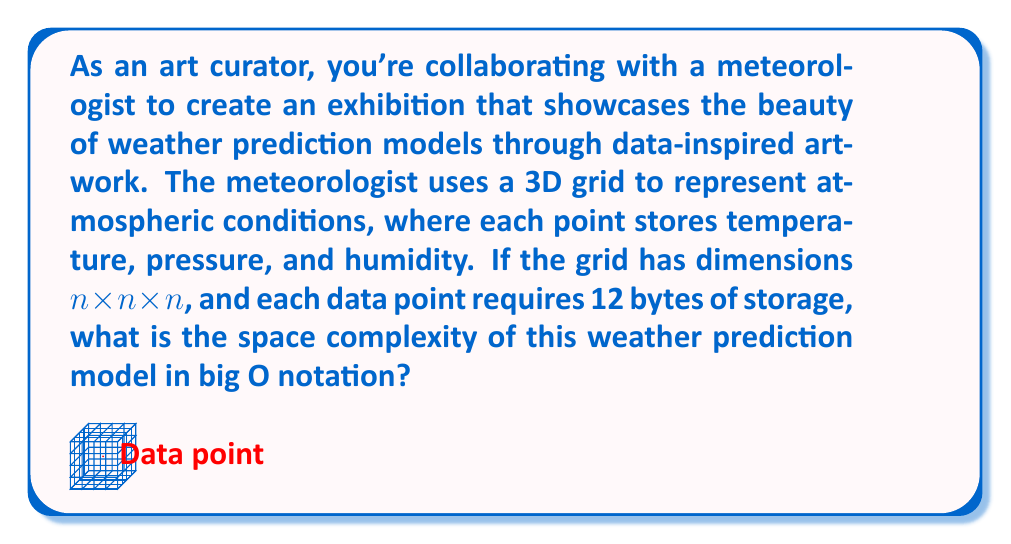Teach me how to tackle this problem. Let's approach this step-by-step:

1) First, we need to understand the structure of the data:
   - We have a 3D grid with dimensions $n \times n \times n$
   - Each point in the grid stores data

2) Calculate the total number of points in the grid:
   - In a 3D grid of $n \times n \times n$, the total number of points is $n^3$

3) Calculate the storage required for each point:
   - Each data point requires 12 bytes of storage

4) Calculate the total storage required:
   - Total storage = Number of points × Storage per point
   - Total storage = $n^3 \times 12$ bytes

5) Express this in terms of big O notation:
   - The constant factor (12 in this case) is ignored in big O notation
   - We're left with $O(n^3)$

6) Interpretation for space complexity:
   - The space complexity grows cubically with the size of the grid dimension

Therefore, the space complexity of this weather prediction model is $O(n^3)$.
Answer: $O(n^3)$ 